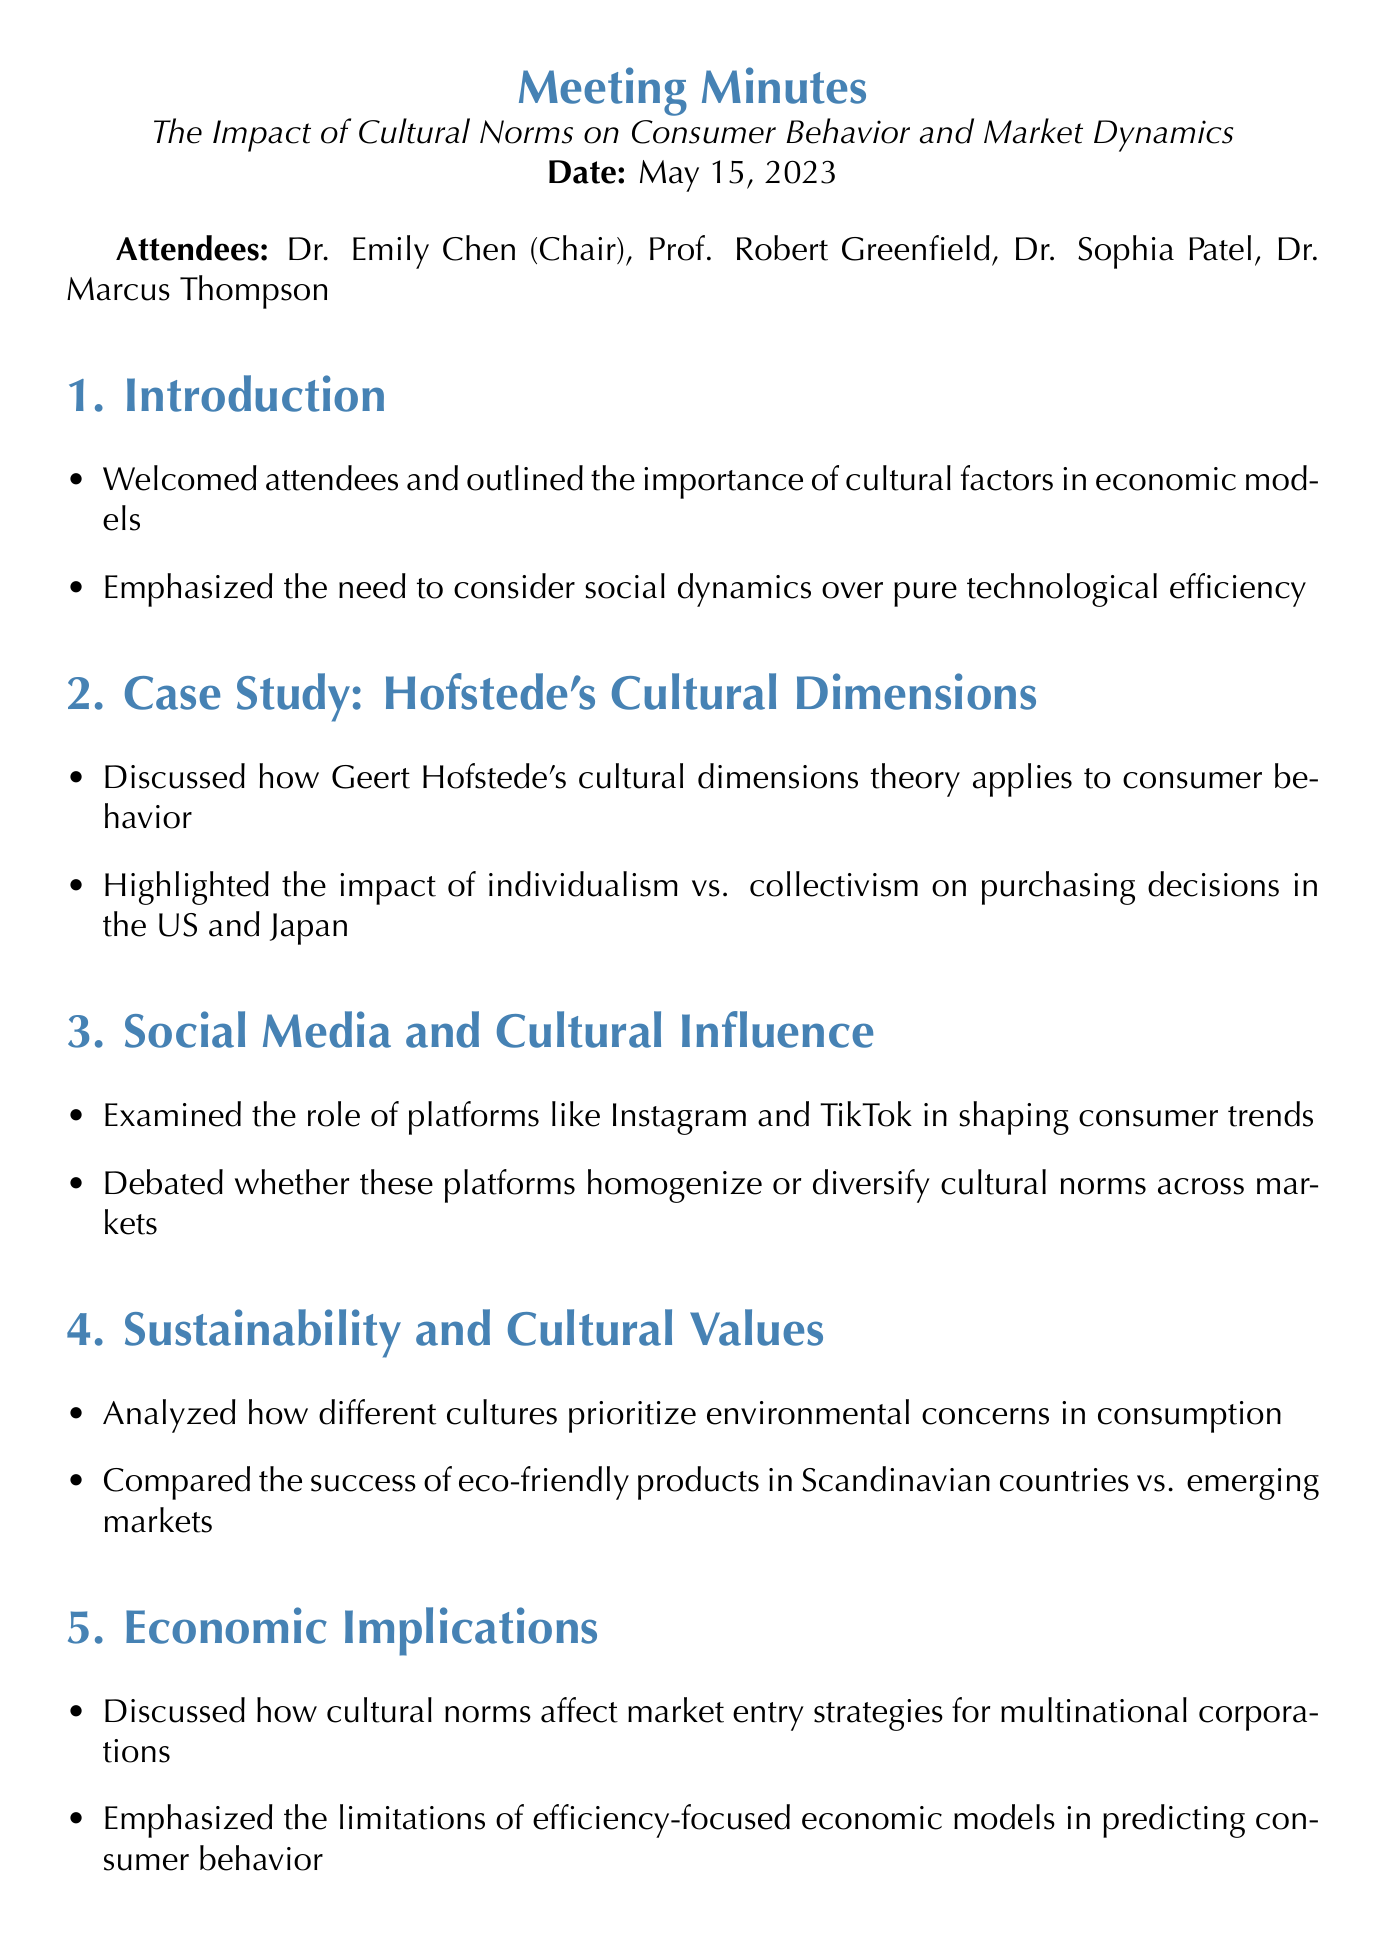what is the meeting title? The meeting title is stated at the top of the document.
Answer: The Impact of Cultural Norms on Consumer Behavior and Market Dynamics who chaired the meeting? The chairperson of the meeting is listed in the attendees section.
Answer: Dr. Emily Chen what date was the meeting held? The date of the meeting is specified at the beginning of the document.
Answer: May 15, 2023 which cultural dimensions theory was discussed? The document lists specific theories discussed in relation to consumer behavior.
Answer: Hofstede's Cultural Dimensions what are the platforms mentioned in relation to cultural influence? The document mentions specific social media platforms that influence consumer trends.
Answer: Instagram and TikTok what was emphasized regarding economic models? The document includes key points made about the limitations of a certain type of economic model.
Answer: Limitations of efficiency-focused economic models how many attendees were present at the meeting? The total number of attendees is provided in the document.
Answer: Four what is the proposed next step after the meeting? The document concludes with a suggestion for future actions following the meeting.
Answer: Follow-up meeting to discuss potential research collaborations 